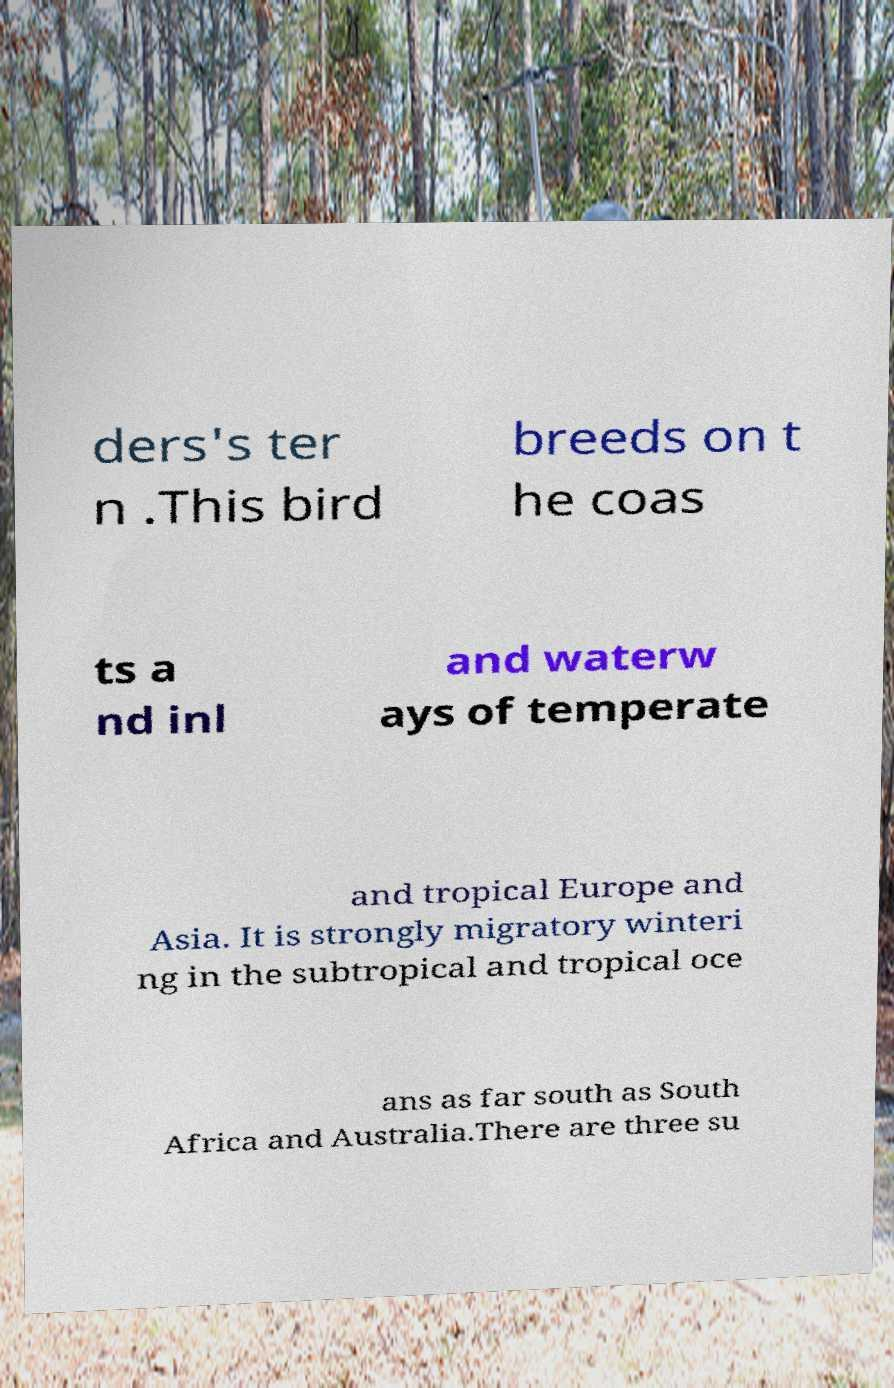Please read and relay the text visible in this image. What does it say? ders's ter n .This bird breeds on t he coas ts a nd inl and waterw ays of temperate and tropical Europe and Asia. It is strongly migratory winteri ng in the subtropical and tropical oce ans as far south as South Africa and Australia.There are three su 